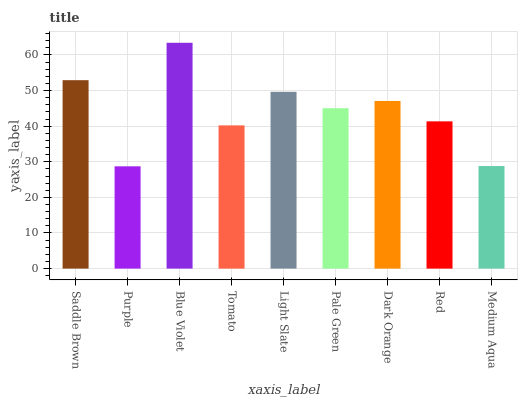Is Purple the minimum?
Answer yes or no. Yes. Is Blue Violet the maximum?
Answer yes or no. Yes. Is Blue Violet the minimum?
Answer yes or no. No. Is Purple the maximum?
Answer yes or no. No. Is Blue Violet greater than Purple?
Answer yes or no. Yes. Is Purple less than Blue Violet?
Answer yes or no. Yes. Is Purple greater than Blue Violet?
Answer yes or no. No. Is Blue Violet less than Purple?
Answer yes or no. No. Is Pale Green the high median?
Answer yes or no. Yes. Is Pale Green the low median?
Answer yes or no. Yes. Is Medium Aqua the high median?
Answer yes or no. No. Is Medium Aqua the low median?
Answer yes or no. No. 